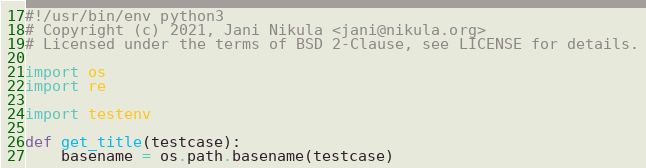<code> <loc_0><loc_0><loc_500><loc_500><_Python_>#!/usr/bin/env python3
# Copyright (c) 2021, Jani Nikula <jani@nikula.org>
# Licensed under the terms of BSD 2-Clause, see LICENSE for details.

import os
import re

import testenv

def get_title(testcase):
    basename = os.path.basename(testcase)
</code> 